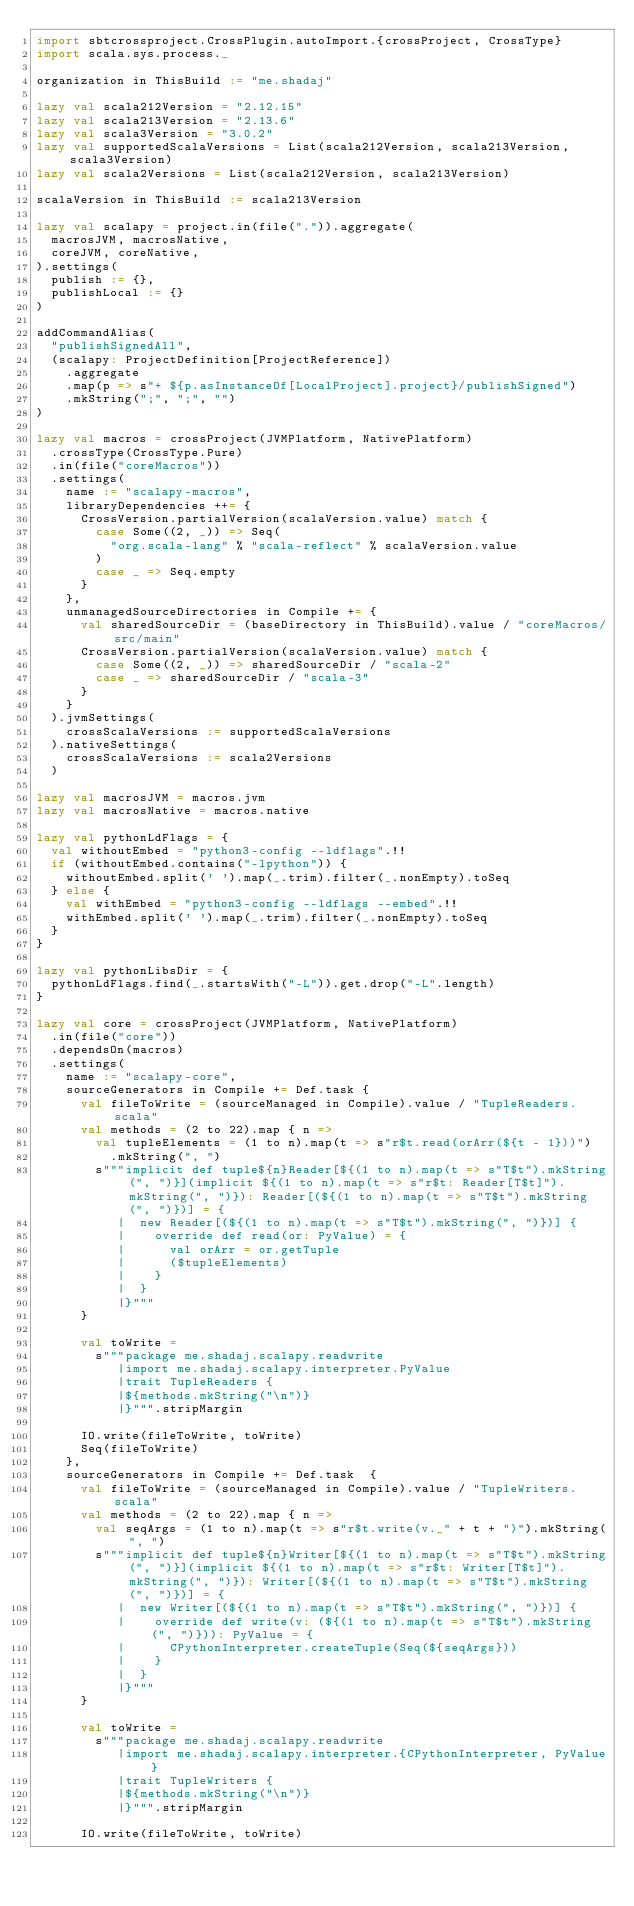Convert code to text. <code><loc_0><loc_0><loc_500><loc_500><_Scala_>import sbtcrossproject.CrossPlugin.autoImport.{crossProject, CrossType}
import scala.sys.process._

organization in ThisBuild := "me.shadaj"

lazy val scala212Version = "2.12.15"
lazy val scala213Version = "2.13.6"
lazy val scala3Version = "3.0.2"
lazy val supportedScalaVersions = List(scala212Version, scala213Version, scala3Version)
lazy val scala2Versions = List(scala212Version, scala213Version)

scalaVersion in ThisBuild := scala213Version

lazy val scalapy = project.in(file(".")).aggregate(
  macrosJVM, macrosNative,
  coreJVM, coreNative,
).settings(
  publish := {},
  publishLocal := {}
)

addCommandAlias(
  "publishSignedAll",
  (scalapy: ProjectDefinition[ProjectReference])
    .aggregate
    .map(p => s"+ ${p.asInstanceOf[LocalProject].project}/publishSigned")
    .mkString(";", ";", "")
)

lazy val macros = crossProject(JVMPlatform, NativePlatform)
  .crossType(CrossType.Pure)
  .in(file("coreMacros"))
  .settings(
    name := "scalapy-macros",
    libraryDependencies ++= {
      CrossVersion.partialVersion(scalaVersion.value) match {
        case Some((2, _)) => Seq(
          "org.scala-lang" % "scala-reflect" % scalaVersion.value
        )
        case _ => Seq.empty
      }
    },
    unmanagedSourceDirectories in Compile += {
      val sharedSourceDir = (baseDirectory in ThisBuild).value / "coreMacros/src/main"
      CrossVersion.partialVersion(scalaVersion.value) match {
        case Some((2, _)) => sharedSourceDir / "scala-2"
        case _ => sharedSourceDir / "scala-3"
      }
    }
  ).jvmSettings(
    crossScalaVersions := supportedScalaVersions
  ).nativeSettings(
    crossScalaVersions := scala2Versions
  )

lazy val macrosJVM = macros.jvm
lazy val macrosNative = macros.native

lazy val pythonLdFlags = {
  val withoutEmbed = "python3-config --ldflags".!!
  if (withoutEmbed.contains("-lpython")) {
    withoutEmbed.split(' ').map(_.trim).filter(_.nonEmpty).toSeq
  } else {
    val withEmbed = "python3-config --ldflags --embed".!!
    withEmbed.split(' ').map(_.trim).filter(_.nonEmpty).toSeq
  }
}

lazy val pythonLibsDir = {
  pythonLdFlags.find(_.startsWith("-L")).get.drop("-L".length)
}

lazy val core = crossProject(JVMPlatform, NativePlatform)
  .in(file("core"))
  .dependsOn(macros)
  .settings(
    name := "scalapy-core",
    sourceGenerators in Compile += Def.task {
      val fileToWrite = (sourceManaged in Compile).value / "TupleReaders.scala"
      val methods = (2 to 22).map { n =>
        val tupleElements = (1 to n).map(t => s"r$t.read(orArr(${t - 1}))")
          .mkString(", ")
        s"""implicit def tuple${n}Reader[${(1 to n).map(t => s"T$t").mkString(", ")}](implicit ${(1 to n).map(t => s"r$t: Reader[T$t]").mkString(", ")}): Reader[(${(1 to n).map(t => s"T$t").mkString(", ")})] = {
           |  new Reader[(${(1 to n).map(t => s"T$t").mkString(", ")})] {
           |    override def read(or: PyValue) = {
           |      val orArr = or.getTuple
           |      ($tupleElements)
           |    }
           |  }
           |}"""
      }

      val toWrite =
        s"""package me.shadaj.scalapy.readwrite
           |import me.shadaj.scalapy.interpreter.PyValue
           |trait TupleReaders {
           |${methods.mkString("\n")}
           |}""".stripMargin

      IO.write(fileToWrite, toWrite)
      Seq(fileToWrite)
    },
    sourceGenerators in Compile += Def.task  {
      val fileToWrite = (sourceManaged in Compile).value / "TupleWriters.scala"
      val methods = (2 to 22).map { n =>
        val seqArgs = (1 to n).map(t => s"r$t.write(v._" + t + ")").mkString(", ")
        s"""implicit def tuple${n}Writer[${(1 to n).map(t => s"T$t").mkString(", ")}](implicit ${(1 to n).map(t => s"r$t: Writer[T$t]").mkString(", ")}): Writer[(${(1 to n).map(t => s"T$t").mkString(", ")})] = {
           |  new Writer[(${(1 to n).map(t => s"T$t").mkString(", ")})] {
           |    override def write(v: (${(1 to n).map(t => s"T$t").mkString(", ")})): PyValue = {
           |      CPythonInterpreter.createTuple(Seq(${seqArgs}))
           |    }
           |  }
           |}"""
      }

      val toWrite =
        s"""package me.shadaj.scalapy.readwrite
           |import me.shadaj.scalapy.interpreter.{CPythonInterpreter, PyValue}
           |trait TupleWriters {
           |${methods.mkString("\n")}
           |}""".stripMargin

      IO.write(fileToWrite, toWrite)</code> 